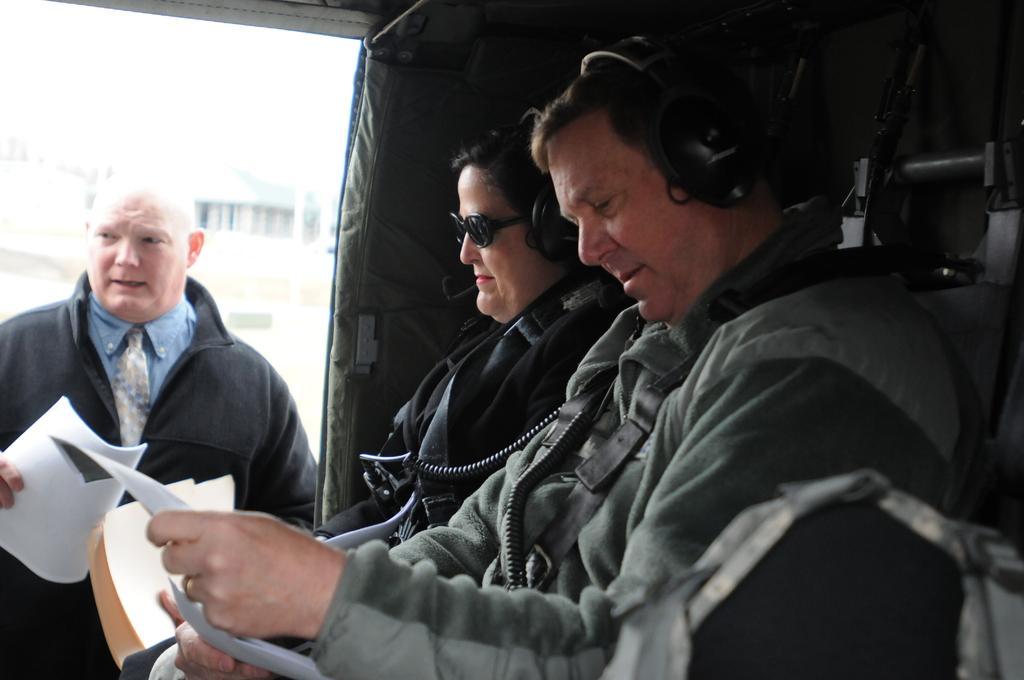Can you describe this image briefly? In the image we can see three people wearing clothes and two of them are wearing headsets. They are papers in their hand. 